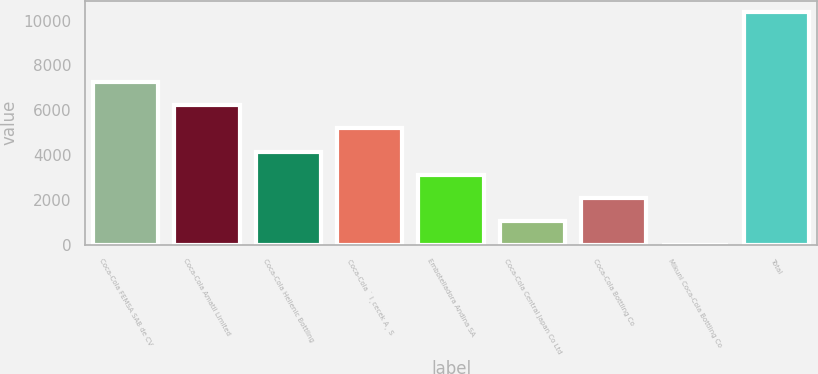Convert chart to OTSL. <chart><loc_0><loc_0><loc_500><loc_500><bar_chart><fcel>Coca-Cola FEMSA SAB de CV<fcel>Coca-Cola Amatil Limited<fcel>Coca-Cola Hellenic Bottling<fcel>Coca-Cola ˙ I¸cecek A¸ S<fcel>Embotelladora Andina SA<fcel>Coca-Cola Central Japan Co Ltd<fcel>Coca-Cola Bottling Co<fcel>Mikuni Coca-Cola Bottling Co<fcel>Total<nl><fcel>7255.1<fcel>6218.8<fcel>4146.2<fcel>5182.5<fcel>3109.9<fcel>1037.3<fcel>2073.6<fcel>1<fcel>10364<nl></chart> 